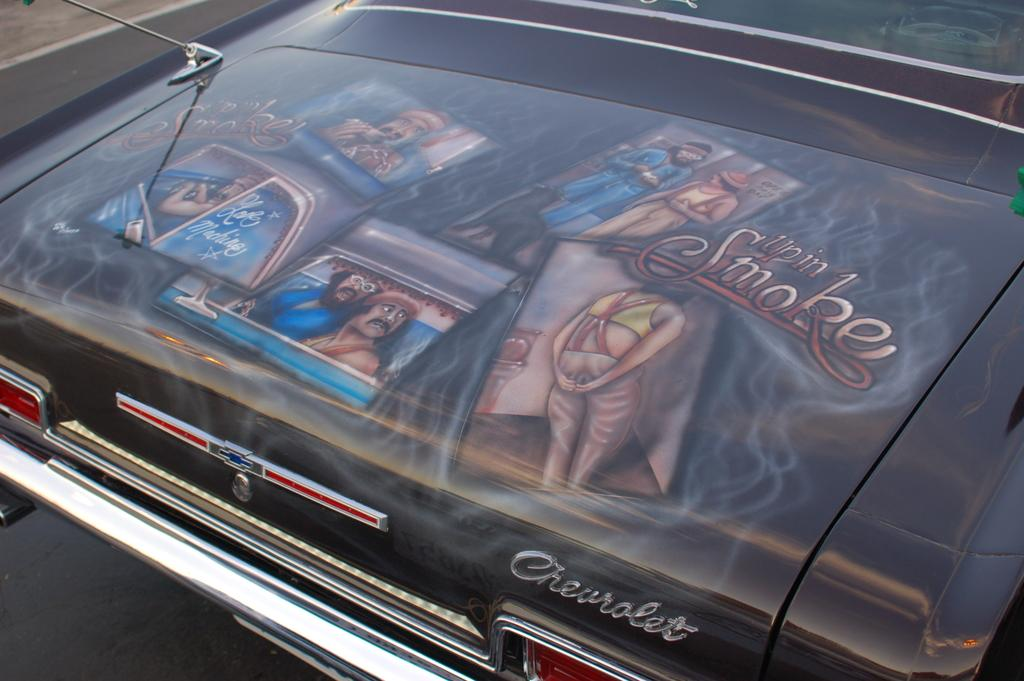What is the main subject of the image? The main subject of the image is a car. Where is the car located in the image? The car is on the road in the image. What additional detail can be observed on the car? There are paintings on the bonnet of the car. What type of business is being conducted in the church in the image? There is no church or business activity present in the image; it features a car with paintings on the bonnet. 